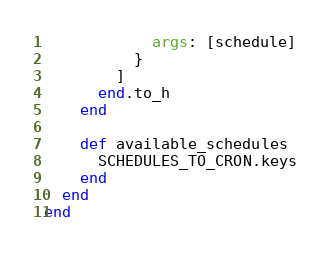Convert code to text. <code><loc_0><loc_0><loc_500><loc_500><_Ruby_>            args: [schedule]
          }
        ]
      end.to_h
    end

    def available_schedules
      SCHEDULES_TO_CRON.keys
    end
  end
end
</code> 